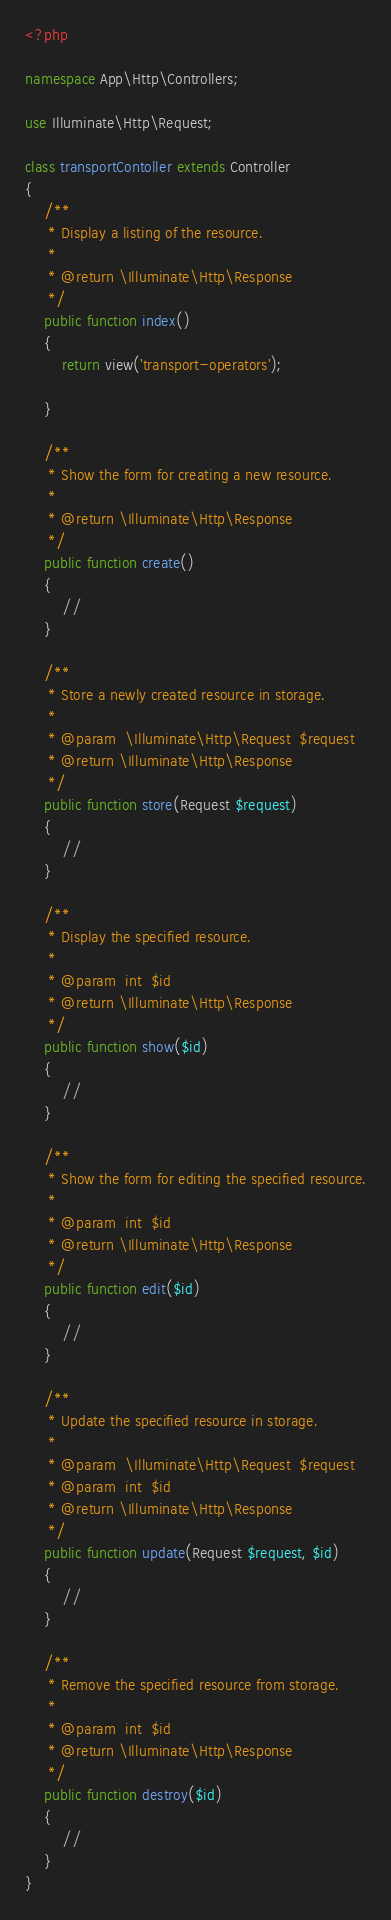<code> <loc_0><loc_0><loc_500><loc_500><_PHP_><?php

namespace App\Http\Controllers;

use Illuminate\Http\Request;

class transportContoller extends Controller
{
    /**
     * Display a listing of the resource.
     *
     * @return \Illuminate\Http\Response
     */
    public function index()
    {
        return view('transport-operators');

    }

    /**
     * Show the form for creating a new resource.
     *
     * @return \Illuminate\Http\Response
     */
    public function create()
    {
        //
    }

    /**
     * Store a newly created resource in storage.
     *
     * @param  \Illuminate\Http\Request  $request
     * @return \Illuminate\Http\Response
     */
    public function store(Request $request)
    {
        //
    }

    /**
     * Display the specified resource.
     *
     * @param  int  $id
     * @return \Illuminate\Http\Response
     */
    public function show($id)
    {
        //
    }

    /**
     * Show the form for editing the specified resource.
     *
     * @param  int  $id
     * @return \Illuminate\Http\Response
     */
    public function edit($id)
    {
        //
    }

    /**
     * Update the specified resource in storage.
     *
     * @param  \Illuminate\Http\Request  $request
     * @param  int  $id
     * @return \Illuminate\Http\Response
     */
    public function update(Request $request, $id)
    {
        //
    }

    /**
     * Remove the specified resource from storage.
     *
     * @param  int  $id
     * @return \Illuminate\Http\Response
     */
    public function destroy($id)
    {
        //
    }
}
</code> 